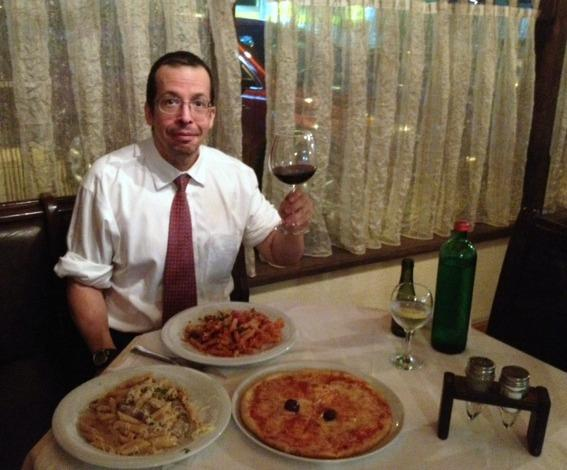Who does the person most look like?

Choices:
A) tim duncan
B) maria sharapova
C) rick moranis
D) serena williams rick moranis 